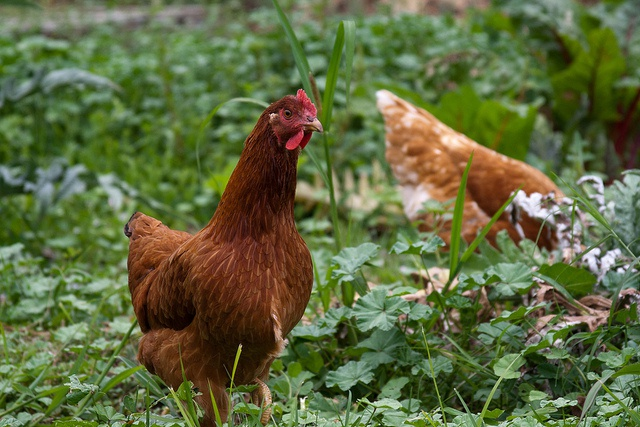Describe the objects in this image and their specific colors. I can see bird in darkgreen, maroon, black, and brown tones and bird in darkgreen, brown, maroon, gray, and tan tones in this image. 